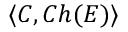<formula> <loc_0><loc_0><loc_500><loc_500>\langle C , C h ( E ) \rangle</formula> 